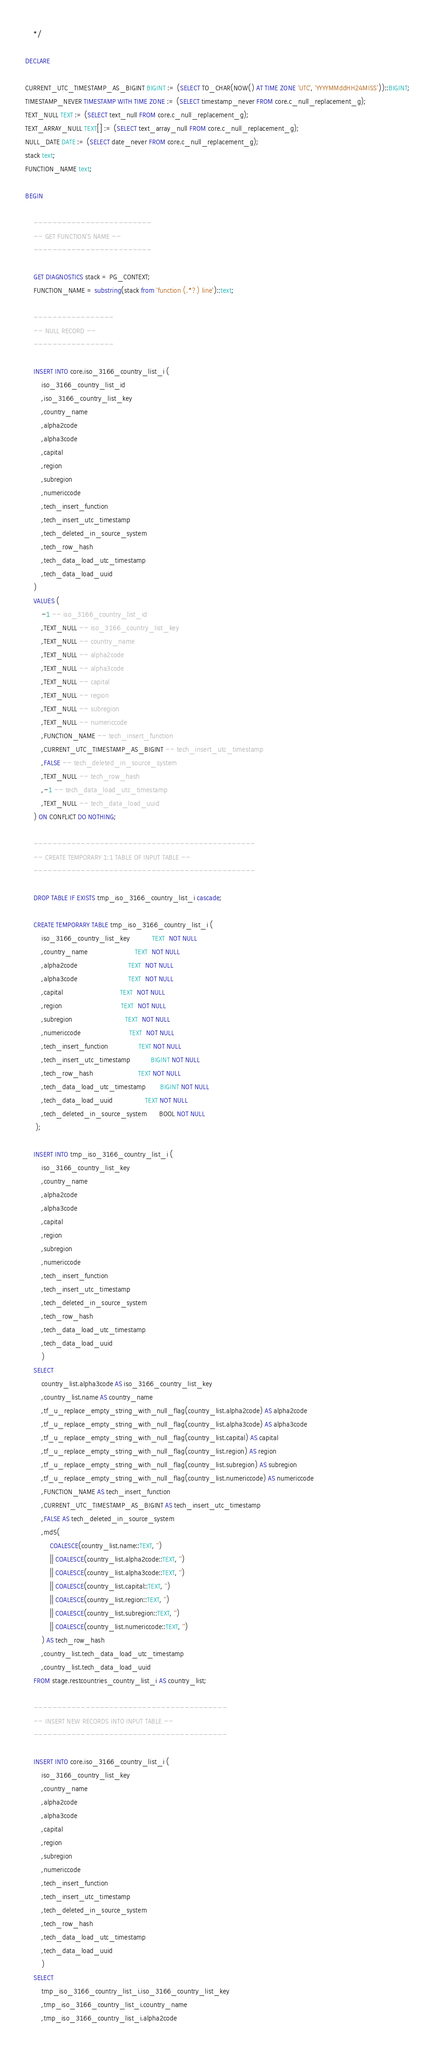<code> <loc_0><loc_0><loc_500><loc_500><_SQL_>    */

DECLARE 

CURRENT_UTC_TIMESTAMP_AS_BIGINT BIGINT := (SELECT TO_CHAR(NOW() AT TIME ZONE 'UTC', 'YYYYMMddHH24MISS'))::BIGINT;
TIMESTAMP_NEVER TIMESTAMP WITH TIME ZONE := (SELECT timestamp_never FROM core.c_null_replacement_g);
TEXT_NULL TEXT := (SELECT text_null FROM core.c_null_replacement_g);
TEXT_ARRAY_NULL TEXT[] := (SELECT text_array_null FROM core.c_null_replacement_g);
NULL_DATE DATE := (SELECT date_never FROM core.c_null_replacement_g);
stack text;
FUNCTION_NAME text;

BEGIN

    -------------------------
    -- GET FUNCTION'S NAME --
    -------------------------

    GET DIAGNOSTICS stack = PG_CONTEXT;
    FUNCTION_NAME = substring(stack from 'function (.*?) line')::text;

    -----------------
    -- NULL RECORD --
    -----------------

    INSERT INTO core.iso_3166_country_list_i (
        iso_3166_country_list_id
        ,iso_3166_country_list_key
        ,country_name
        ,alpha2code
        ,alpha3code
        ,capital
        ,region
        ,subregion
        ,numericcode
        ,tech_insert_function
        ,tech_insert_utc_timestamp
        ,tech_deleted_in_source_system
        ,tech_row_hash
        ,tech_data_load_utc_timestamp
        ,tech_data_load_uuid
    )
    VALUES (
        -1 -- iso_3166_country_list_id
        ,TEXT_NULL -- iso_3166_country_list_key
        ,TEXT_NULL -- country_name
        ,TEXT_NULL -- alpha2code
        ,TEXT_NULL -- alpha3code
        ,TEXT_NULL -- capital
        ,TEXT_NULL -- region
        ,TEXT_NULL -- subregion
        ,TEXT_NULL -- numericcode
        ,FUNCTION_NAME -- tech_insert_function
        ,CURRENT_UTC_TIMESTAMP_AS_BIGINT -- tech_insert_utc_timestamp
        ,FALSE -- tech_deleted_in_source_system
        ,TEXT_NULL -- tech_row_hash
        ,-1 -- tech_data_load_utc_timestamp
        ,TEXT_NULL -- tech_data_load_uuid
    ) ON CONFLICT DO NOTHING;

    -----------------------------------------------
    -- CREATE TEMPORARY 1:1 TABLE OF INPUT TABLE --
    -----------------------------------------------

    DROP TABLE IF EXISTS tmp_iso_3166_country_list_i cascade;

    CREATE TEMPORARY TABLE tmp_iso_3166_country_list_i (
        iso_3166_country_list_key           TEXT  NOT NULL
        ,country_name                       TEXT  NOT NULL
        ,alpha2code                         TEXT  NOT NULL
        ,alpha3code                         TEXT  NOT NULL
        ,capital                            TEXT  NOT NULL
        ,region                             TEXT  NOT NULL
        ,subregion                          TEXT  NOT NULL
        ,numericcode                        TEXT  NOT NULL
        ,tech_insert_function               TEXT NOT NULL
        ,tech_insert_utc_timestamp          BIGINT NOT NULL
        ,tech_row_hash                      TEXT NOT NULL
        ,tech_data_load_utc_timestamp       BIGINT NOT NULL
        ,tech_data_load_uuid                TEXT NOT NULL
        ,tech_deleted_in_source_system      BOOL NOT NULL
     );

    INSERT INTO tmp_iso_3166_country_list_i (
        iso_3166_country_list_key
        ,country_name
        ,alpha2code
        ,alpha3code
        ,capital
        ,region
        ,subregion
        ,numericcode
        ,tech_insert_function
        ,tech_insert_utc_timestamp
        ,tech_deleted_in_source_system
        ,tech_row_hash
        ,tech_data_load_utc_timestamp
        ,tech_data_load_uuid
        )
    SELECT
        country_list.alpha3code AS iso_3166_country_list_key
        ,country_list.name AS country_name
        ,tf_u_replace_empty_string_with_null_flag(country_list.alpha2code) AS alpha2code
        ,tf_u_replace_empty_string_with_null_flag(country_list.alpha3code) AS alpha3code
        ,tf_u_replace_empty_string_with_null_flag(country_list.capital) AS capital
        ,tf_u_replace_empty_string_with_null_flag(country_list.region) AS region
        ,tf_u_replace_empty_string_with_null_flag(country_list.subregion) AS subregion 
        ,tf_u_replace_empty_string_with_null_flag(country_list.numericcode) AS numericcode
        ,FUNCTION_NAME AS tech_insert_function
        ,CURRENT_UTC_TIMESTAMP_AS_BIGINT AS tech_insert_utc_timestamp
        ,FALSE AS tech_deleted_in_source_system
        ,md5(
            COALESCE(country_list.name::TEXT, '')
            || COALESCE(country_list.alpha2code::TEXT, '')
            || COALESCE(country_list.alpha3code::TEXT, '')
            || COALESCE(country_list.capital::TEXT, '')
            || COALESCE(country_list.region::TEXT, '')
            || COALESCE(country_list.subregion::TEXT, '')
            || COALESCE(country_list.numericcode::TEXT, '')
        ) AS tech_row_hash
        ,country_list.tech_data_load_utc_timestamp
        ,country_list.tech_data_load_uuid
    FROM stage.restcountries_country_list_i AS country_list;

    -----------------------------------------
    -- INSERT NEW RECORDS INTO INPUT TABLE --
    -----------------------------------------

    INSERT INTO core.iso_3166_country_list_i (
        iso_3166_country_list_key
        ,country_name
        ,alpha2code
        ,alpha3code
        ,capital
        ,region
        ,subregion
        ,numericcode
        ,tech_insert_function
        ,tech_insert_utc_timestamp
        ,tech_deleted_in_source_system
        ,tech_row_hash
        ,tech_data_load_utc_timestamp
        ,tech_data_load_uuid
        )
    SELECT 
        tmp_iso_3166_country_list_i.iso_3166_country_list_key
        ,tmp_iso_3166_country_list_i.country_name
        ,tmp_iso_3166_country_list_i.alpha2code</code> 